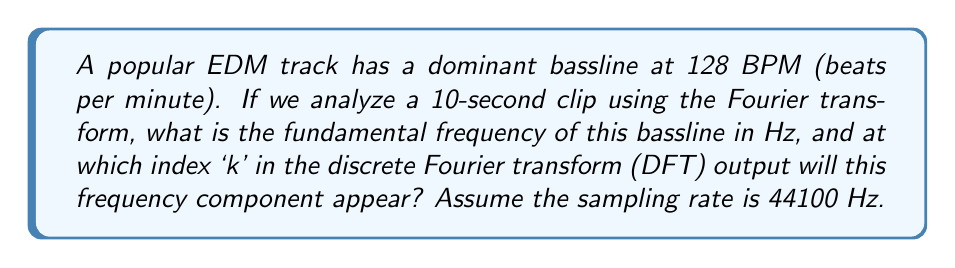Could you help me with this problem? Let's approach this step-by-step:

1) First, we need to convert BPM to Hz:
   $$ f = \frac{128 \text{ BPM}}{60 \text{ seconds}} = 2.133 \text{ Hz} $$

2) This is our fundamental frequency for the bassline.

3) For the DFT, we need to know the frequency resolution. With a 10-second clip, the frequency resolution is:
   $$ \Delta f = \frac{1}{T} = \frac{1}{10 \text{ s}} = 0.1 \text{ Hz} $$

4) The index k in the DFT output corresponds to multiples of this frequency resolution. To find k, we divide our fundamental frequency by the frequency resolution:
   $$ k = \frac{f}{\Delta f} = \frac{2.133 \text{ Hz}}{0.1 \text{ Hz}} = 21.33 $$

5) Since k must be an integer, we round to the nearest whole number: k = 21

6) To verify, let's calculate the exact frequency this k represents:
   $$ f_k = k \cdot \Delta f = 21 \cdot 0.1 \text{ Hz} = 2.1 \text{ Hz} $$

   This is very close to our original 2.133 Hz, confirming our calculation.

7) Note: In a real DFT, we would have N = sampling rate * duration = 44100 * 10 = 441000 total frequency bins, but we're focusing on the low-frequency component here.
Answer: The fundamental frequency of the bassline is 2.133 Hz, and it will appear at index k = 21 in the DFT output. 